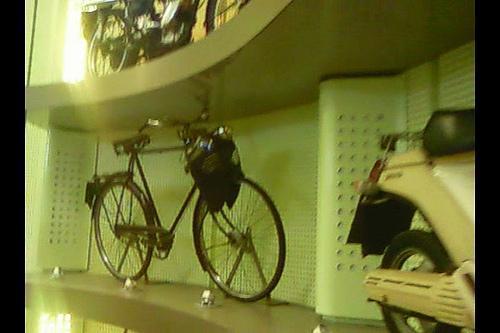How many models are in this picture?
Give a very brief answer. 3. How many seats does the bike have?
Give a very brief answer. 1. How many wheels does the bike have?
Give a very brief answer. 2. 